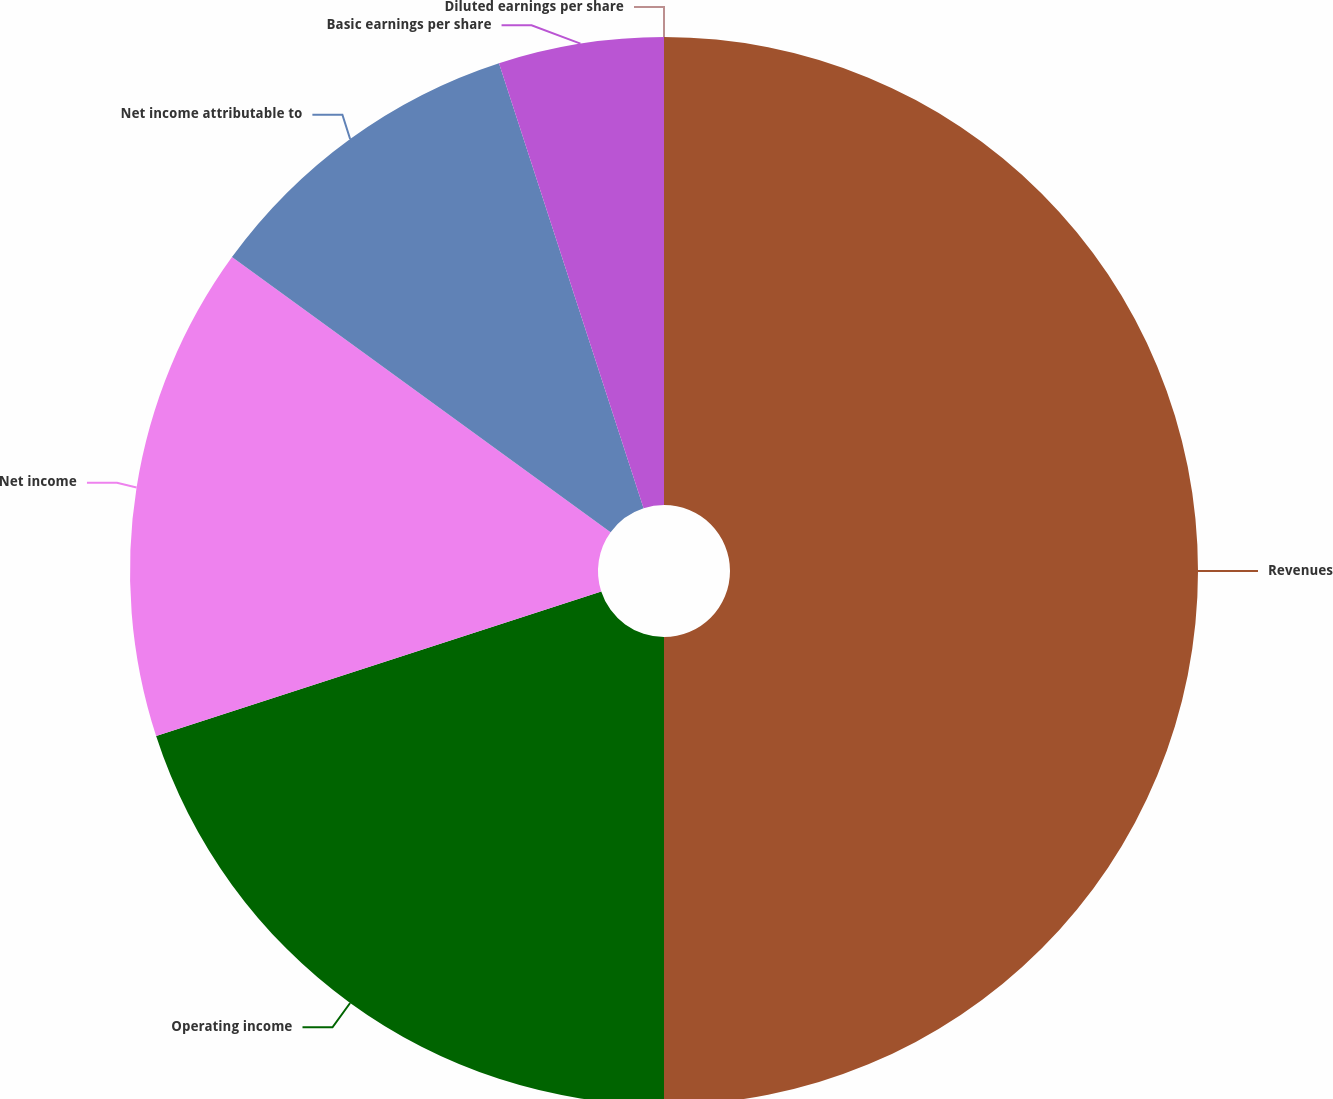<chart> <loc_0><loc_0><loc_500><loc_500><pie_chart><fcel>Revenues<fcel>Operating income<fcel>Net income<fcel>Net income attributable to<fcel>Basic earnings per share<fcel>Diluted earnings per share<nl><fcel>50.0%<fcel>20.0%<fcel>15.0%<fcel>10.0%<fcel>5.0%<fcel>0.0%<nl></chart> 